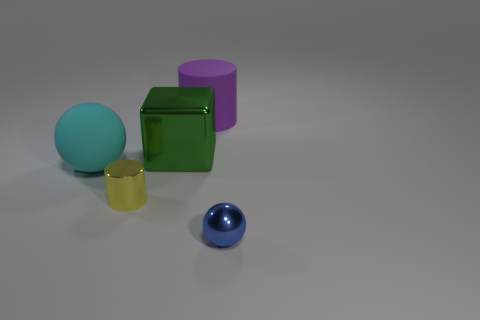What number of gray things are either small objects or cylinders?
Ensure brevity in your answer.  0. What number of metal objects are the same color as the large matte sphere?
Offer a terse response. 0. Is there any other thing that is the same shape as the tiny yellow thing?
Make the answer very short. Yes. What number of cubes are either large rubber objects or blue things?
Keep it short and to the point. 0. There is a small object that is on the left side of the tiny sphere; what color is it?
Your response must be concise. Yellow. There is a green object that is the same size as the purple rubber cylinder; what is its shape?
Make the answer very short. Cube. There is a yellow cylinder; how many tiny blue shiny things are to the left of it?
Offer a very short reply. 0. What number of objects are shiny cubes or balls?
Your answer should be compact. 3. What is the shape of the object that is both to the right of the big green thing and in front of the cyan rubber ball?
Provide a short and direct response. Sphere. How many tiny red rubber blocks are there?
Ensure brevity in your answer.  0. 